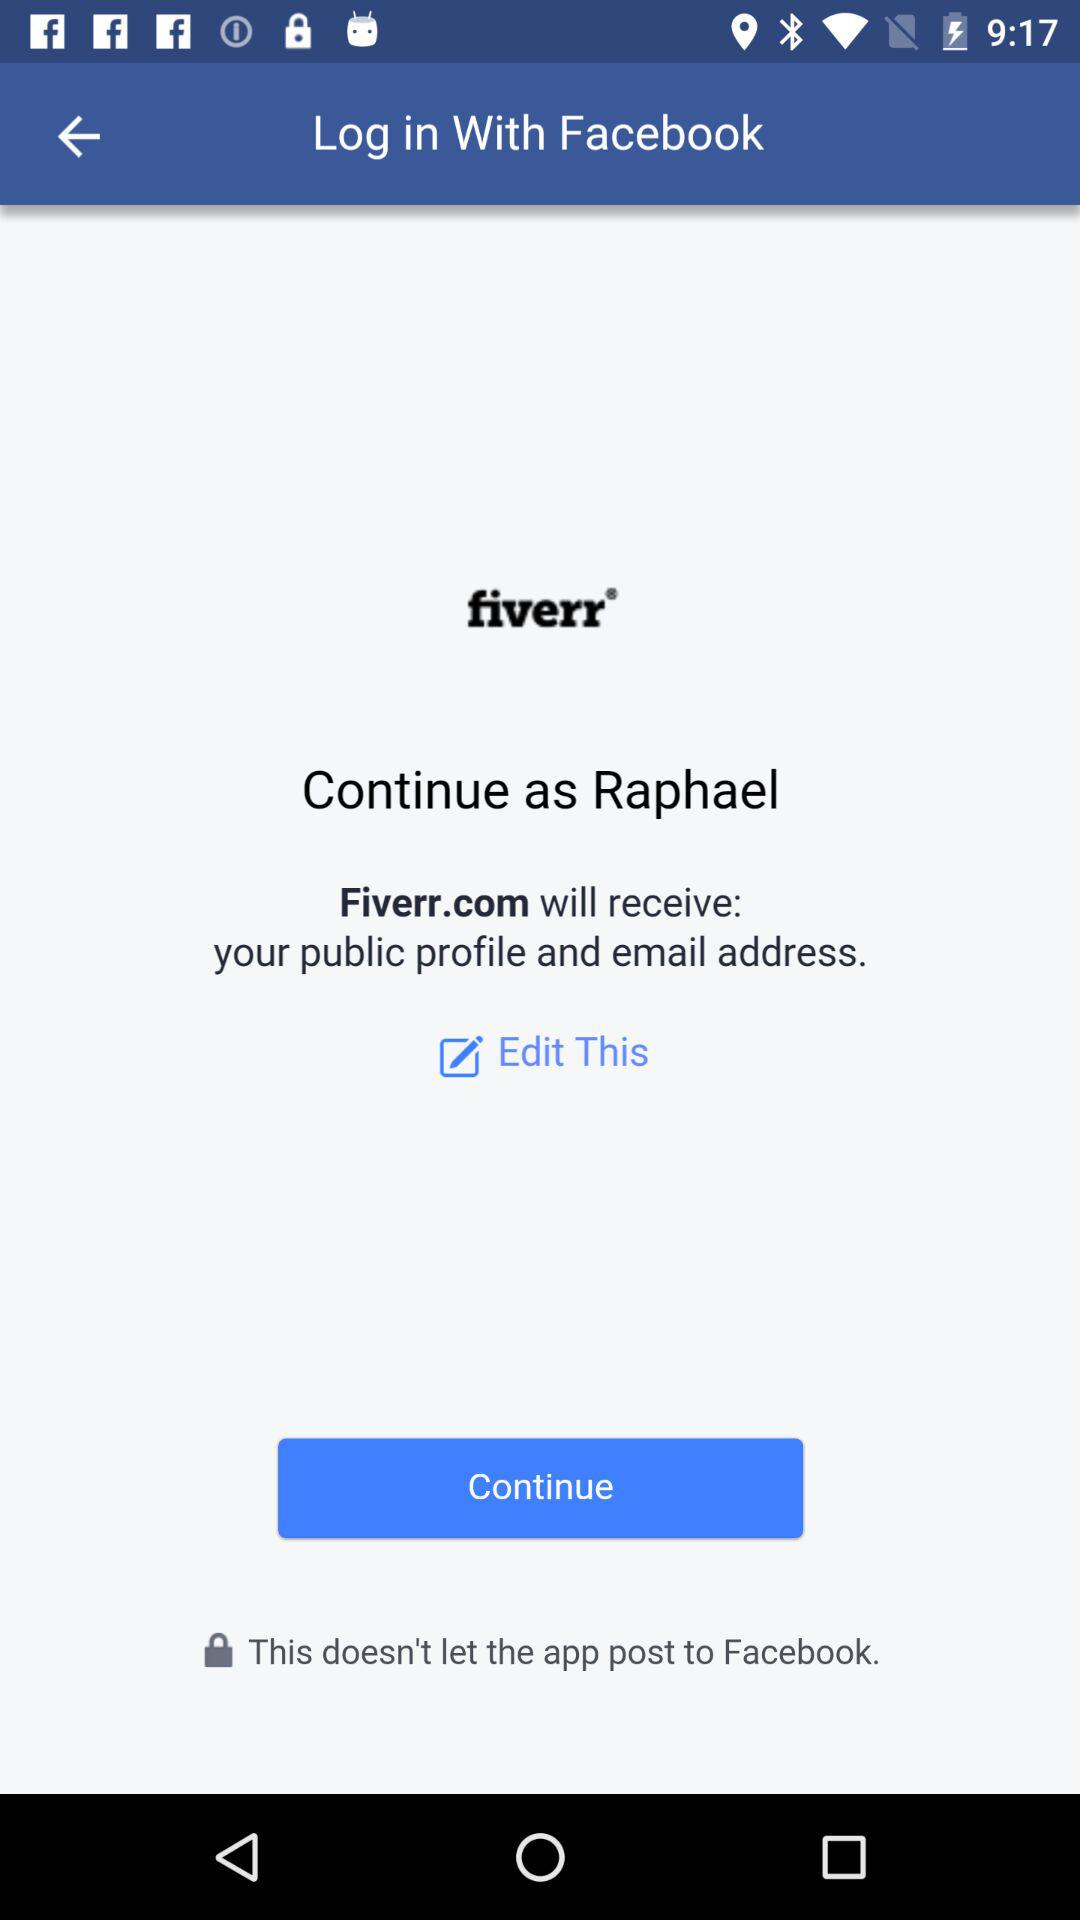Through what application can a user log in with? The application that can be used to log in by the user is Facebook. 